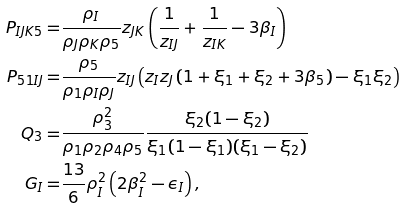Convert formula to latex. <formula><loc_0><loc_0><loc_500><loc_500>P _ { I J K 5 } = & \frac { \rho _ { I } } { \rho _ { J } \rho _ { K } \rho _ { 5 } } z _ { J K } \left ( \frac { 1 } { z _ { I J } } + \frac { 1 } { z _ { I K } } - 3 \beta _ { I } \right ) \\ P _ { 5 1 I J } = & \frac { \rho _ { 5 } } { \rho _ { 1 } \rho _ { I } \rho _ { J } } z _ { I J } \left ( z _ { I } z _ { J } \left ( 1 + \xi _ { 1 } + \xi _ { 2 } + 3 \beta _ { 5 } \right ) - \xi _ { 1 } \xi _ { 2 } \right ) \\ Q _ { 3 } = & \frac { \rho _ { 3 } ^ { 2 } } { \rho _ { 1 } \rho _ { 2 } \rho _ { 4 } \rho _ { 5 } } \frac { \xi _ { 2 } ( 1 - \xi _ { 2 } ) } { \xi _ { 1 } ( 1 - \xi _ { 1 } ) ( \xi _ { 1 } - \xi _ { 2 } ) } \\ G _ { I } = & \frac { 1 3 } { 6 } \rho _ { I } ^ { 2 } \left ( 2 \beta _ { I } ^ { 2 } - \epsilon _ { I } \right ) ,</formula> 